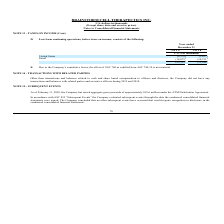From Brainstorm Cell Therapeutics's financial document, What is the loss from continuing operations, before taxes on income, in the United States in 2019 and 2018 respectively? The document shows two values: 4,378 and 3,617 (in thousands). From the document: "United States (4,378) (3,617) United States (4,378) (3,617)..." Also, What is the loss from continuing operations, before taxes on income, in Israel in 2019 and 2018 respectively? The document shows two values: 18,875 and 10,331 (in thousands). From the document: "Israel (18,875) (10,331) Israel (18,875) (10,331)..." Also, What is the total loss from continuing operations, before taxes on income, for the year ended December 31, 2019? According to the financial document, 23,253 (in thousands). The relevant text states: "(23,253 ) (13,948 )..." Also, can you calculate: What is the change in loss from continuing operations, before taxes on income, in U.S. from 2018 to 2019? Based on the calculation: 4,378-3,617, the result is 761 (in thousands). This is based on the information: "United States (4,378) (3,617) United States (4,378) (3,617)..." The key data points involved are: 3,617, 4,378. Also, can you calculate: What is the percentage change in the total loss from continuing operations, before taxes on income, from 2018 to 2019? To answer this question, I need to perform calculations using the financial data. The calculation is: (23,253-13,948)/13,948, which equals 66.71 (percentage). This is based on the information: "(23,253 ) (13,948 ) (23,253 ) (13,948 )..." The key data points involved are: 13,948, 23,253. Also, can you calculate: What is the percentage of Israel's loss from continuing operations, before taxes on income, for the year ended 2019? Based on the calculation: 18,875/23,253, the result is 81.17 (percentage). This is based on the information: "(23,253 ) (13,948 ) Israel (18,875) (10,331)..." The key data points involved are: 18,875, 23,253. 